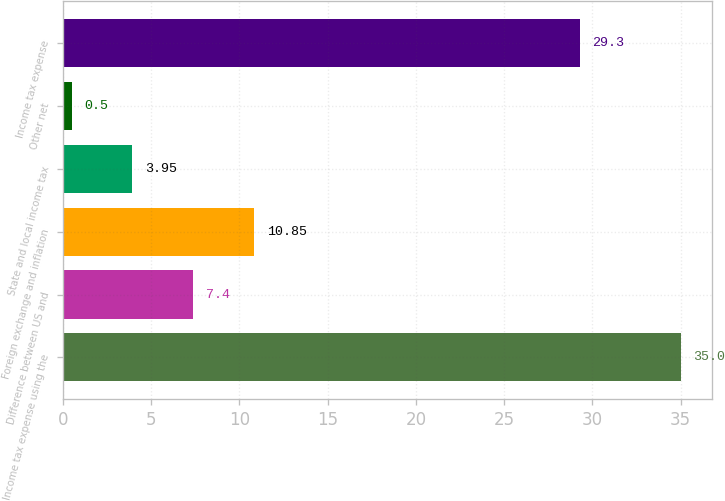Convert chart to OTSL. <chart><loc_0><loc_0><loc_500><loc_500><bar_chart><fcel>Income tax expense using the<fcel>Difference between US and<fcel>Foreign exchange and inflation<fcel>State and local income tax<fcel>Other net<fcel>Income tax expense<nl><fcel>35<fcel>7.4<fcel>10.85<fcel>3.95<fcel>0.5<fcel>29.3<nl></chart> 